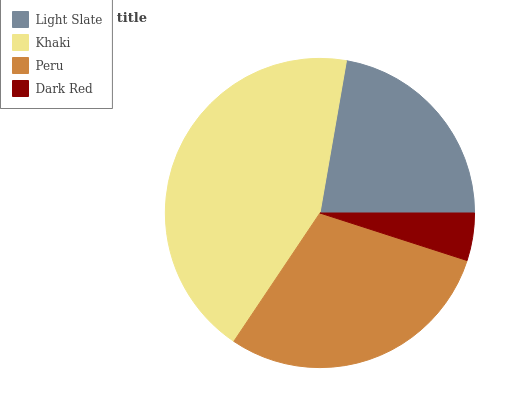Is Dark Red the minimum?
Answer yes or no. Yes. Is Khaki the maximum?
Answer yes or no. Yes. Is Peru the minimum?
Answer yes or no. No. Is Peru the maximum?
Answer yes or no. No. Is Khaki greater than Peru?
Answer yes or no. Yes. Is Peru less than Khaki?
Answer yes or no. Yes. Is Peru greater than Khaki?
Answer yes or no. No. Is Khaki less than Peru?
Answer yes or no. No. Is Peru the high median?
Answer yes or no. Yes. Is Light Slate the low median?
Answer yes or no. Yes. Is Light Slate the high median?
Answer yes or no. No. Is Dark Red the low median?
Answer yes or no. No. 